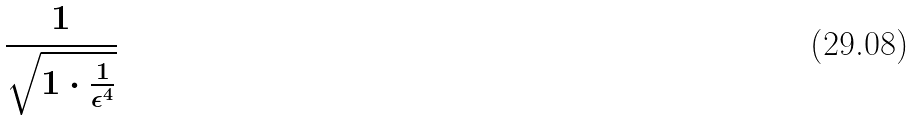<formula> <loc_0><loc_0><loc_500><loc_500>\frac { 1 } { \sqrt { 1 \cdot \frac { 1 } { \epsilon ^ { 4 } } } }</formula> 